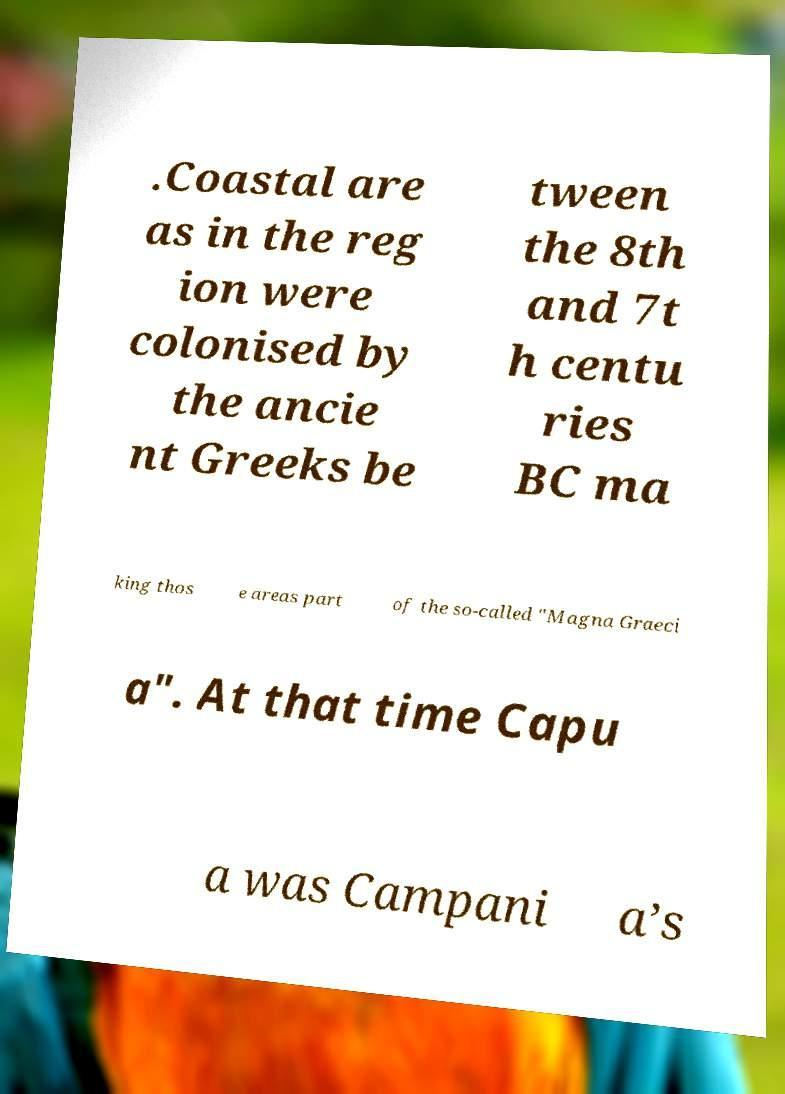Can you read and provide the text displayed in the image?This photo seems to have some interesting text. Can you extract and type it out for me? .Coastal are as in the reg ion were colonised by the ancie nt Greeks be tween the 8th and 7t h centu ries BC ma king thos e areas part of the so-called "Magna Graeci a". At that time Capu a was Campani a’s 